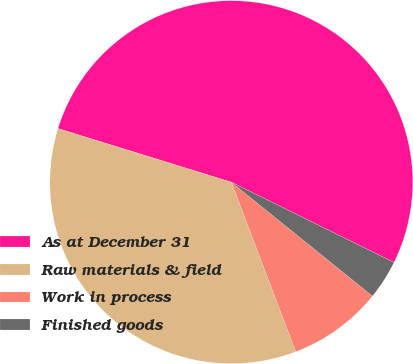Convert chart to OTSL. <chart><loc_0><loc_0><loc_500><loc_500><pie_chart><fcel>As at December 31<fcel>Raw materials & field<fcel>Work in process<fcel>Finished goods<nl><fcel>52.52%<fcel>35.56%<fcel>8.41%<fcel>3.51%<nl></chart> 